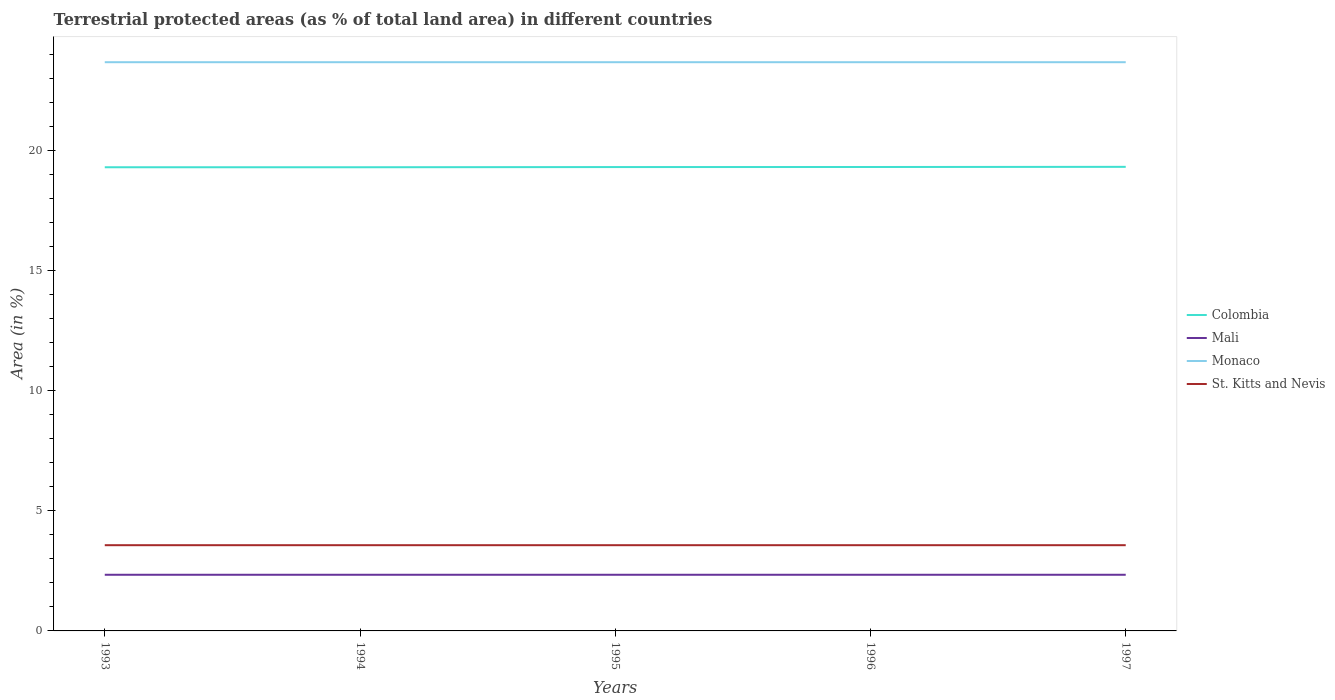How many different coloured lines are there?
Your response must be concise. 4. Does the line corresponding to Monaco intersect with the line corresponding to Mali?
Offer a very short reply. No. Across all years, what is the maximum percentage of terrestrial protected land in Monaco?
Give a very brief answer. 23.68. In which year was the percentage of terrestrial protected land in St. Kitts and Nevis maximum?
Your response must be concise. 1993. What is the difference between the highest and the second highest percentage of terrestrial protected land in Colombia?
Keep it short and to the point. 0.02. What is the difference between the highest and the lowest percentage of terrestrial protected land in Colombia?
Keep it short and to the point. 3. Is the percentage of terrestrial protected land in Monaco strictly greater than the percentage of terrestrial protected land in Colombia over the years?
Your answer should be very brief. No. How many lines are there?
Keep it short and to the point. 4. Does the graph contain any zero values?
Offer a terse response. No. Does the graph contain grids?
Your response must be concise. No. Where does the legend appear in the graph?
Give a very brief answer. Center right. What is the title of the graph?
Provide a short and direct response. Terrestrial protected areas (as % of total land area) in different countries. Does "Sub-Saharan Africa (developing only)" appear as one of the legend labels in the graph?
Give a very brief answer. No. What is the label or title of the Y-axis?
Your answer should be very brief. Area (in %). What is the Area (in %) in Colombia in 1993?
Keep it short and to the point. 19.31. What is the Area (in %) in Mali in 1993?
Keep it short and to the point. 2.34. What is the Area (in %) of Monaco in 1993?
Make the answer very short. 23.68. What is the Area (in %) in St. Kitts and Nevis in 1993?
Offer a terse response. 3.57. What is the Area (in %) in Colombia in 1994?
Offer a very short reply. 19.31. What is the Area (in %) in Mali in 1994?
Make the answer very short. 2.34. What is the Area (in %) of Monaco in 1994?
Give a very brief answer. 23.68. What is the Area (in %) in St. Kitts and Nevis in 1994?
Ensure brevity in your answer.  3.57. What is the Area (in %) in Colombia in 1995?
Provide a short and direct response. 19.32. What is the Area (in %) of Mali in 1995?
Keep it short and to the point. 2.34. What is the Area (in %) of Monaco in 1995?
Give a very brief answer. 23.68. What is the Area (in %) in St. Kitts and Nevis in 1995?
Make the answer very short. 3.57. What is the Area (in %) in Colombia in 1996?
Provide a short and direct response. 19.32. What is the Area (in %) in Mali in 1996?
Give a very brief answer. 2.34. What is the Area (in %) in Monaco in 1996?
Provide a short and direct response. 23.68. What is the Area (in %) of St. Kitts and Nevis in 1996?
Offer a very short reply. 3.57. What is the Area (in %) of Colombia in 1997?
Provide a short and direct response. 19.33. What is the Area (in %) in Mali in 1997?
Your answer should be very brief. 2.34. What is the Area (in %) in Monaco in 1997?
Offer a very short reply. 23.68. What is the Area (in %) of St. Kitts and Nevis in 1997?
Provide a short and direct response. 3.57. Across all years, what is the maximum Area (in %) in Colombia?
Your answer should be compact. 19.33. Across all years, what is the maximum Area (in %) of Mali?
Offer a terse response. 2.34. Across all years, what is the maximum Area (in %) of Monaco?
Give a very brief answer. 23.68. Across all years, what is the maximum Area (in %) of St. Kitts and Nevis?
Offer a very short reply. 3.57. Across all years, what is the minimum Area (in %) in Colombia?
Offer a terse response. 19.31. Across all years, what is the minimum Area (in %) in Mali?
Provide a succinct answer. 2.34. Across all years, what is the minimum Area (in %) in Monaco?
Your answer should be very brief. 23.68. Across all years, what is the minimum Area (in %) of St. Kitts and Nevis?
Offer a terse response. 3.57. What is the total Area (in %) in Colombia in the graph?
Keep it short and to the point. 96.58. What is the total Area (in %) in Mali in the graph?
Your answer should be compact. 11.69. What is the total Area (in %) in Monaco in the graph?
Offer a terse response. 118.42. What is the total Area (in %) of St. Kitts and Nevis in the graph?
Offer a very short reply. 17.85. What is the difference between the Area (in %) in Monaco in 1993 and that in 1994?
Your response must be concise. 0. What is the difference between the Area (in %) of St. Kitts and Nevis in 1993 and that in 1994?
Your answer should be compact. 0. What is the difference between the Area (in %) in Colombia in 1993 and that in 1995?
Give a very brief answer. -0.01. What is the difference between the Area (in %) of St. Kitts and Nevis in 1993 and that in 1995?
Give a very brief answer. 0. What is the difference between the Area (in %) of Colombia in 1993 and that in 1996?
Ensure brevity in your answer.  -0.01. What is the difference between the Area (in %) in Monaco in 1993 and that in 1996?
Make the answer very short. 0. What is the difference between the Area (in %) in St. Kitts and Nevis in 1993 and that in 1996?
Provide a short and direct response. 0. What is the difference between the Area (in %) in Colombia in 1993 and that in 1997?
Give a very brief answer. -0.02. What is the difference between the Area (in %) in Colombia in 1994 and that in 1995?
Keep it short and to the point. -0.01. What is the difference between the Area (in %) of Mali in 1994 and that in 1995?
Keep it short and to the point. 0. What is the difference between the Area (in %) in Monaco in 1994 and that in 1995?
Your answer should be compact. 0. What is the difference between the Area (in %) in St. Kitts and Nevis in 1994 and that in 1995?
Give a very brief answer. 0. What is the difference between the Area (in %) in Colombia in 1994 and that in 1996?
Give a very brief answer. -0.01. What is the difference between the Area (in %) in Mali in 1994 and that in 1996?
Your response must be concise. -0. What is the difference between the Area (in %) of St. Kitts and Nevis in 1994 and that in 1996?
Your answer should be very brief. 0. What is the difference between the Area (in %) of Colombia in 1994 and that in 1997?
Provide a succinct answer. -0.02. What is the difference between the Area (in %) of Mali in 1994 and that in 1997?
Keep it short and to the point. -0. What is the difference between the Area (in %) of Colombia in 1995 and that in 1996?
Offer a terse response. -0. What is the difference between the Area (in %) of Colombia in 1995 and that in 1997?
Your response must be concise. -0.01. What is the difference between the Area (in %) of Colombia in 1996 and that in 1997?
Ensure brevity in your answer.  -0.01. What is the difference between the Area (in %) in Mali in 1996 and that in 1997?
Ensure brevity in your answer.  0. What is the difference between the Area (in %) in Monaco in 1996 and that in 1997?
Ensure brevity in your answer.  0. What is the difference between the Area (in %) of St. Kitts and Nevis in 1996 and that in 1997?
Keep it short and to the point. 0. What is the difference between the Area (in %) in Colombia in 1993 and the Area (in %) in Mali in 1994?
Provide a succinct answer. 16.97. What is the difference between the Area (in %) of Colombia in 1993 and the Area (in %) of Monaco in 1994?
Provide a short and direct response. -4.37. What is the difference between the Area (in %) of Colombia in 1993 and the Area (in %) of St. Kitts and Nevis in 1994?
Ensure brevity in your answer.  15.74. What is the difference between the Area (in %) of Mali in 1993 and the Area (in %) of Monaco in 1994?
Offer a terse response. -21.35. What is the difference between the Area (in %) in Mali in 1993 and the Area (in %) in St. Kitts and Nevis in 1994?
Your answer should be compact. -1.23. What is the difference between the Area (in %) in Monaco in 1993 and the Area (in %) in St. Kitts and Nevis in 1994?
Your answer should be very brief. 20.11. What is the difference between the Area (in %) in Colombia in 1993 and the Area (in %) in Mali in 1995?
Your answer should be very brief. 16.97. What is the difference between the Area (in %) in Colombia in 1993 and the Area (in %) in Monaco in 1995?
Your answer should be compact. -4.37. What is the difference between the Area (in %) of Colombia in 1993 and the Area (in %) of St. Kitts and Nevis in 1995?
Ensure brevity in your answer.  15.74. What is the difference between the Area (in %) of Mali in 1993 and the Area (in %) of Monaco in 1995?
Give a very brief answer. -21.35. What is the difference between the Area (in %) in Mali in 1993 and the Area (in %) in St. Kitts and Nevis in 1995?
Your response must be concise. -1.23. What is the difference between the Area (in %) in Monaco in 1993 and the Area (in %) in St. Kitts and Nevis in 1995?
Make the answer very short. 20.11. What is the difference between the Area (in %) of Colombia in 1993 and the Area (in %) of Mali in 1996?
Make the answer very short. 16.97. What is the difference between the Area (in %) in Colombia in 1993 and the Area (in %) in Monaco in 1996?
Give a very brief answer. -4.37. What is the difference between the Area (in %) in Colombia in 1993 and the Area (in %) in St. Kitts and Nevis in 1996?
Provide a succinct answer. 15.74. What is the difference between the Area (in %) in Mali in 1993 and the Area (in %) in Monaco in 1996?
Keep it short and to the point. -21.35. What is the difference between the Area (in %) of Mali in 1993 and the Area (in %) of St. Kitts and Nevis in 1996?
Give a very brief answer. -1.23. What is the difference between the Area (in %) of Monaco in 1993 and the Area (in %) of St. Kitts and Nevis in 1996?
Provide a succinct answer. 20.11. What is the difference between the Area (in %) in Colombia in 1993 and the Area (in %) in Mali in 1997?
Keep it short and to the point. 16.97. What is the difference between the Area (in %) of Colombia in 1993 and the Area (in %) of Monaco in 1997?
Your answer should be compact. -4.37. What is the difference between the Area (in %) of Colombia in 1993 and the Area (in %) of St. Kitts and Nevis in 1997?
Provide a short and direct response. 15.74. What is the difference between the Area (in %) in Mali in 1993 and the Area (in %) in Monaco in 1997?
Offer a very short reply. -21.35. What is the difference between the Area (in %) in Mali in 1993 and the Area (in %) in St. Kitts and Nevis in 1997?
Give a very brief answer. -1.23. What is the difference between the Area (in %) of Monaco in 1993 and the Area (in %) of St. Kitts and Nevis in 1997?
Ensure brevity in your answer.  20.11. What is the difference between the Area (in %) in Colombia in 1994 and the Area (in %) in Mali in 1995?
Provide a succinct answer. 16.97. What is the difference between the Area (in %) in Colombia in 1994 and the Area (in %) in Monaco in 1995?
Ensure brevity in your answer.  -4.37. What is the difference between the Area (in %) of Colombia in 1994 and the Area (in %) of St. Kitts and Nevis in 1995?
Provide a short and direct response. 15.74. What is the difference between the Area (in %) in Mali in 1994 and the Area (in %) in Monaco in 1995?
Provide a succinct answer. -21.35. What is the difference between the Area (in %) of Mali in 1994 and the Area (in %) of St. Kitts and Nevis in 1995?
Offer a terse response. -1.23. What is the difference between the Area (in %) of Monaco in 1994 and the Area (in %) of St. Kitts and Nevis in 1995?
Your answer should be compact. 20.11. What is the difference between the Area (in %) of Colombia in 1994 and the Area (in %) of Mali in 1996?
Make the answer very short. 16.97. What is the difference between the Area (in %) of Colombia in 1994 and the Area (in %) of Monaco in 1996?
Keep it short and to the point. -4.37. What is the difference between the Area (in %) in Colombia in 1994 and the Area (in %) in St. Kitts and Nevis in 1996?
Your answer should be compact. 15.74. What is the difference between the Area (in %) of Mali in 1994 and the Area (in %) of Monaco in 1996?
Provide a succinct answer. -21.35. What is the difference between the Area (in %) of Mali in 1994 and the Area (in %) of St. Kitts and Nevis in 1996?
Ensure brevity in your answer.  -1.23. What is the difference between the Area (in %) of Monaco in 1994 and the Area (in %) of St. Kitts and Nevis in 1996?
Your response must be concise. 20.11. What is the difference between the Area (in %) of Colombia in 1994 and the Area (in %) of Mali in 1997?
Your answer should be compact. 16.97. What is the difference between the Area (in %) of Colombia in 1994 and the Area (in %) of Monaco in 1997?
Provide a succinct answer. -4.37. What is the difference between the Area (in %) in Colombia in 1994 and the Area (in %) in St. Kitts and Nevis in 1997?
Your answer should be very brief. 15.74. What is the difference between the Area (in %) in Mali in 1994 and the Area (in %) in Monaco in 1997?
Give a very brief answer. -21.35. What is the difference between the Area (in %) of Mali in 1994 and the Area (in %) of St. Kitts and Nevis in 1997?
Offer a terse response. -1.23. What is the difference between the Area (in %) in Monaco in 1994 and the Area (in %) in St. Kitts and Nevis in 1997?
Keep it short and to the point. 20.11. What is the difference between the Area (in %) in Colombia in 1995 and the Area (in %) in Mali in 1996?
Give a very brief answer. 16.98. What is the difference between the Area (in %) in Colombia in 1995 and the Area (in %) in Monaco in 1996?
Provide a succinct answer. -4.37. What is the difference between the Area (in %) of Colombia in 1995 and the Area (in %) of St. Kitts and Nevis in 1996?
Offer a very short reply. 15.75. What is the difference between the Area (in %) of Mali in 1995 and the Area (in %) of Monaco in 1996?
Offer a very short reply. -21.35. What is the difference between the Area (in %) of Mali in 1995 and the Area (in %) of St. Kitts and Nevis in 1996?
Your answer should be very brief. -1.23. What is the difference between the Area (in %) of Monaco in 1995 and the Area (in %) of St. Kitts and Nevis in 1996?
Your answer should be very brief. 20.11. What is the difference between the Area (in %) of Colombia in 1995 and the Area (in %) of Mali in 1997?
Keep it short and to the point. 16.98. What is the difference between the Area (in %) of Colombia in 1995 and the Area (in %) of Monaco in 1997?
Provide a succinct answer. -4.37. What is the difference between the Area (in %) of Colombia in 1995 and the Area (in %) of St. Kitts and Nevis in 1997?
Provide a short and direct response. 15.75. What is the difference between the Area (in %) of Mali in 1995 and the Area (in %) of Monaco in 1997?
Your answer should be very brief. -21.35. What is the difference between the Area (in %) in Mali in 1995 and the Area (in %) in St. Kitts and Nevis in 1997?
Keep it short and to the point. -1.23. What is the difference between the Area (in %) of Monaco in 1995 and the Area (in %) of St. Kitts and Nevis in 1997?
Offer a very short reply. 20.11. What is the difference between the Area (in %) of Colombia in 1996 and the Area (in %) of Mali in 1997?
Your answer should be compact. 16.98. What is the difference between the Area (in %) in Colombia in 1996 and the Area (in %) in Monaco in 1997?
Keep it short and to the point. -4.36. What is the difference between the Area (in %) of Colombia in 1996 and the Area (in %) of St. Kitts and Nevis in 1997?
Keep it short and to the point. 15.75. What is the difference between the Area (in %) in Mali in 1996 and the Area (in %) in Monaco in 1997?
Your answer should be compact. -21.35. What is the difference between the Area (in %) of Mali in 1996 and the Area (in %) of St. Kitts and Nevis in 1997?
Offer a very short reply. -1.23. What is the difference between the Area (in %) in Monaco in 1996 and the Area (in %) in St. Kitts and Nevis in 1997?
Your response must be concise. 20.11. What is the average Area (in %) in Colombia per year?
Keep it short and to the point. 19.32. What is the average Area (in %) in Mali per year?
Offer a terse response. 2.34. What is the average Area (in %) of Monaco per year?
Offer a very short reply. 23.68. What is the average Area (in %) of St. Kitts and Nevis per year?
Give a very brief answer. 3.57. In the year 1993, what is the difference between the Area (in %) of Colombia and Area (in %) of Mali?
Offer a terse response. 16.97. In the year 1993, what is the difference between the Area (in %) in Colombia and Area (in %) in Monaco?
Offer a terse response. -4.37. In the year 1993, what is the difference between the Area (in %) of Colombia and Area (in %) of St. Kitts and Nevis?
Provide a short and direct response. 15.74. In the year 1993, what is the difference between the Area (in %) in Mali and Area (in %) in Monaco?
Offer a terse response. -21.35. In the year 1993, what is the difference between the Area (in %) in Mali and Area (in %) in St. Kitts and Nevis?
Offer a terse response. -1.23. In the year 1993, what is the difference between the Area (in %) of Monaco and Area (in %) of St. Kitts and Nevis?
Make the answer very short. 20.11. In the year 1994, what is the difference between the Area (in %) of Colombia and Area (in %) of Mali?
Give a very brief answer. 16.97. In the year 1994, what is the difference between the Area (in %) in Colombia and Area (in %) in Monaco?
Your answer should be compact. -4.37. In the year 1994, what is the difference between the Area (in %) of Colombia and Area (in %) of St. Kitts and Nevis?
Your response must be concise. 15.74. In the year 1994, what is the difference between the Area (in %) of Mali and Area (in %) of Monaco?
Offer a terse response. -21.35. In the year 1994, what is the difference between the Area (in %) of Mali and Area (in %) of St. Kitts and Nevis?
Make the answer very short. -1.23. In the year 1994, what is the difference between the Area (in %) in Monaco and Area (in %) in St. Kitts and Nevis?
Your response must be concise. 20.11. In the year 1995, what is the difference between the Area (in %) in Colombia and Area (in %) in Mali?
Give a very brief answer. 16.98. In the year 1995, what is the difference between the Area (in %) of Colombia and Area (in %) of Monaco?
Provide a succinct answer. -4.37. In the year 1995, what is the difference between the Area (in %) of Colombia and Area (in %) of St. Kitts and Nevis?
Give a very brief answer. 15.75. In the year 1995, what is the difference between the Area (in %) in Mali and Area (in %) in Monaco?
Your answer should be compact. -21.35. In the year 1995, what is the difference between the Area (in %) in Mali and Area (in %) in St. Kitts and Nevis?
Make the answer very short. -1.23. In the year 1995, what is the difference between the Area (in %) in Monaco and Area (in %) in St. Kitts and Nevis?
Provide a succinct answer. 20.11. In the year 1996, what is the difference between the Area (in %) in Colombia and Area (in %) in Mali?
Offer a terse response. 16.98. In the year 1996, what is the difference between the Area (in %) in Colombia and Area (in %) in Monaco?
Ensure brevity in your answer.  -4.36. In the year 1996, what is the difference between the Area (in %) of Colombia and Area (in %) of St. Kitts and Nevis?
Your answer should be very brief. 15.75. In the year 1996, what is the difference between the Area (in %) of Mali and Area (in %) of Monaco?
Provide a short and direct response. -21.35. In the year 1996, what is the difference between the Area (in %) in Mali and Area (in %) in St. Kitts and Nevis?
Offer a very short reply. -1.23. In the year 1996, what is the difference between the Area (in %) of Monaco and Area (in %) of St. Kitts and Nevis?
Offer a terse response. 20.11. In the year 1997, what is the difference between the Area (in %) in Colombia and Area (in %) in Mali?
Your answer should be very brief. 16.99. In the year 1997, what is the difference between the Area (in %) in Colombia and Area (in %) in Monaco?
Ensure brevity in your answer.  -4.36. In the year 1997, what is the difference between the Area (in %) in Colombia and Area (in %) in St. Kitts and Nevis?
Your answer should be very brief. 15.76. In the year 1997, what is the difference between the Area (in %) in Mali and Area (in %) in Monaco?
Ensure brevity in your answer.  -21.35. In the year 1997, what is the difference between the Area (in %) of Mali and Area (in %) of St. Kitts and Nevis?
Offer a very short reply. -1.23. In the year 1997, what is the difference between the Area (in %) of Monaco and Area (in %) of St. Kitts and Nevis?
Your response must be concise. 20.11. What is the ratio of the Area (in %) of Monaco in 1993 to that in 1994?
Your response must be concise. 1. What is the ratio of the Area (in %) in St. Kitts and Nevis in 1993 to that in 1994?
Give a very brief answer. 1. What is the ratio of the Area (in %) in Monaco in 1993 to that in 1995?
Provide a succinct answer. 1. What is the ratio of the Area (in %) of St. Kitts and Nevis in 1993 to that in 1995?
Offer a terse response. 1. What is the ratio of the Area (in %) of Mali in 1993 to that in 1996?
Your answer should be compact. 1. What is the ratio of the Area (in %) in St. Kitts and Nevis in 1993 to that in 1996?
Give a very brief answer. 1. What is the ratio of the Area (in %) of Mali in 1993 to that in 1997?
Give a very brief answer. 1. What is the ratio of the Area (in %) in Monaco in 1993 to that in 1997?
Provide a succinct answer. 1. What is the ratio of the Area (in %) of St. Kitts and Nevis in 1993 to that in 1997?
Offer a very short reply. 1. What is the ratio of the Area (in %) in Mali in 1994 to that in 1995?
Ensure brevity in your answer.  1. What is the ratio of the Area (in %) of St. Kitts and Nevis in 1994 to that in 1995?
Give a very brief answer. 1. What is the ratio of the Area (in %) of Colombia in 1994 to that in 1997?
Keep it short and to the point. 1. What is the ratio of the Area (in %) of Mali in 1994 to that in 1997?
Offer a very short reply. 1. What is the ratio of the Area (in %) of Mali in 1995 to that in 1996?
Provide a succinct answer. 1. What is the ratio of the Area (in %) of Colombia in 1995 to that in 1997?
Your answer should be compact. 1. What is the ratio of the Area (in %) of Mali in 1995 to that in 1997?
Offer a terse response. 1. What is the ratio of the Area (in %) of St. Kitts and Nevis in 1995 to that in 1997?
Your answer should be very brief. 1. What is the ratio of the Area (in %) of Colombia in 1996 to that in 1997?
Your answer should be compact. 1. What is the ratio of the Area (in %) in Monaco in 1996 to that in 1997?
Make the answer very short. 1. What is the difference between the highest and the second highest Area (in %) in Colombia?
Provide a short and direct response. 0.01. What is the difference between the highest and the second highest Area (in %) of Mali?
Your answer should be very brief. 0. What is the difference between the highest and the lowest Area (in %) in Colombia?
Make the answer very short. 0.02. What is the difference between the highest and the lowest Area (in %) of Monaco?
Your answer should be very brief. 0. What is the difference between the highest and the lowest Area (in %) in St. Kitts and Nevis?
Offer a very short reply. 0. 